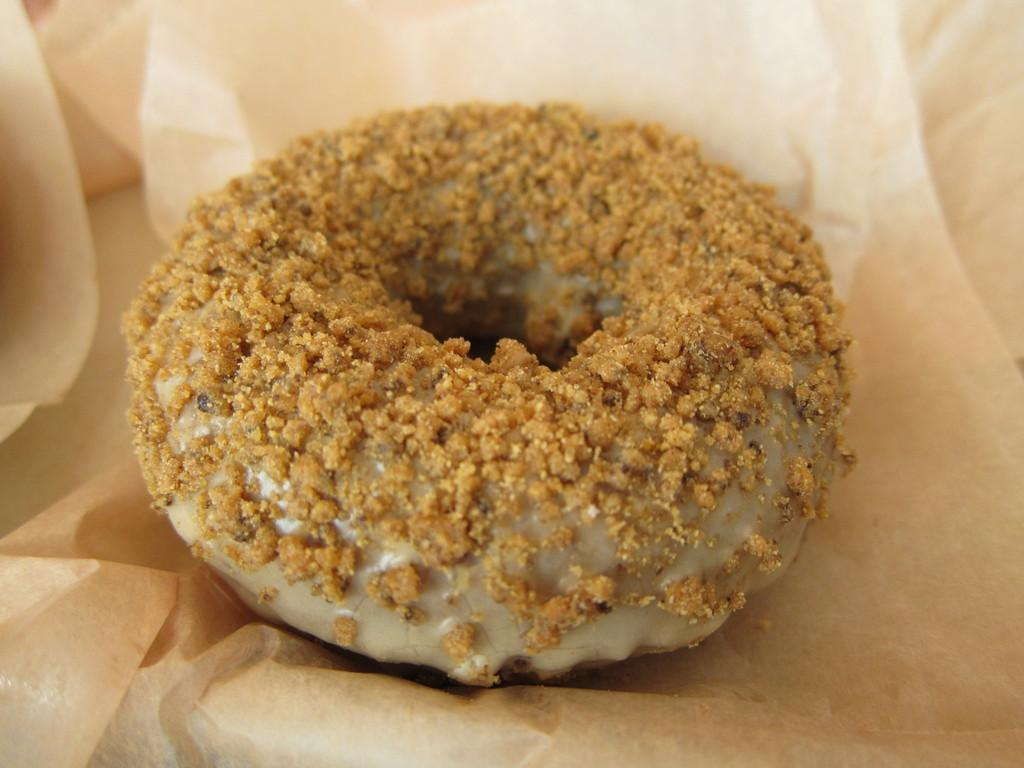What type of food item is visible in the image? There is a sweet in the image. Where is the sweet placed? The sweet is placed on a paper. What type of church can be seen in the image? There is no church present in the image; it only features a sweet placed on a paper. 